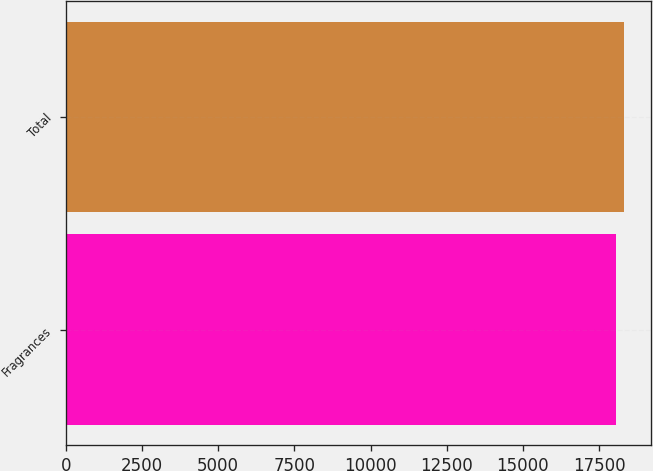Convert chart. <chart><loc_0><loc_0><loc_500><loc_500><bar_chart><fcel>Fragrances<fcel>Total<nl><fcel>18046<fcel>18301<nl></chart> 